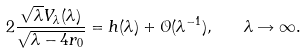<formula> <loc_0><loc_0><loc_500><loc_500>2 \frac { \sqrt { \lambda } V _ { \lambda } ( \lambda ) } { \sqrt { \lambda - 4 r _ { 0 } } } = h ( \lambda ) + \mathcal { O } ( \lambda ^ { - 1 } ) , \quad \lambda \rightarrow \infty .</formula> 